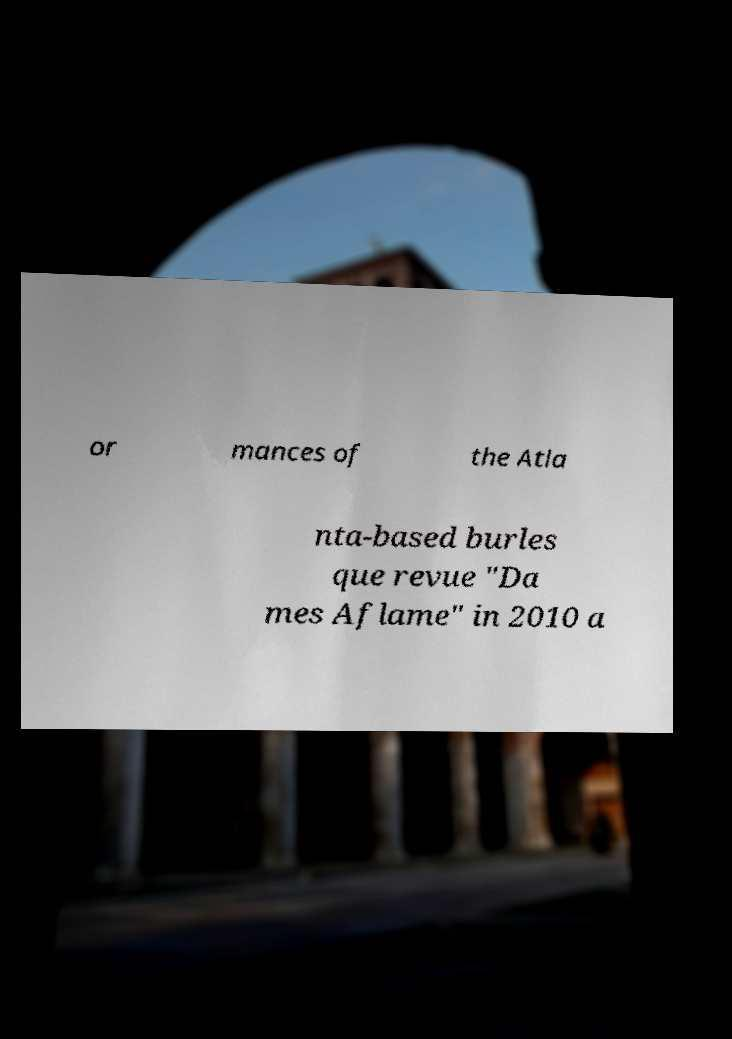Can you read and provide the text displayed in the image?This photo seems to have some interesting text. Can you extract and type it out for me? or mances of the Atla nta-based burles que revue "Da mes Aflame" in 2010 a 